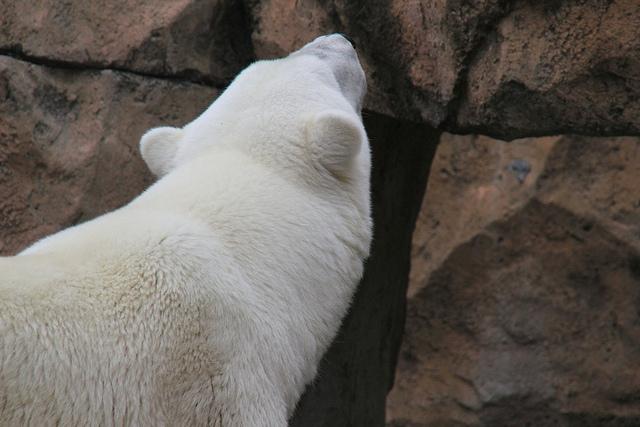Is this animal in a zoo?
Give a very brief answer. Yes. What is the polar bear doing?
Give a very brief answer. Looking. What animal is this?
Concise answer only. Polar bear. Is this a black bear?
Quick response, please. No. 